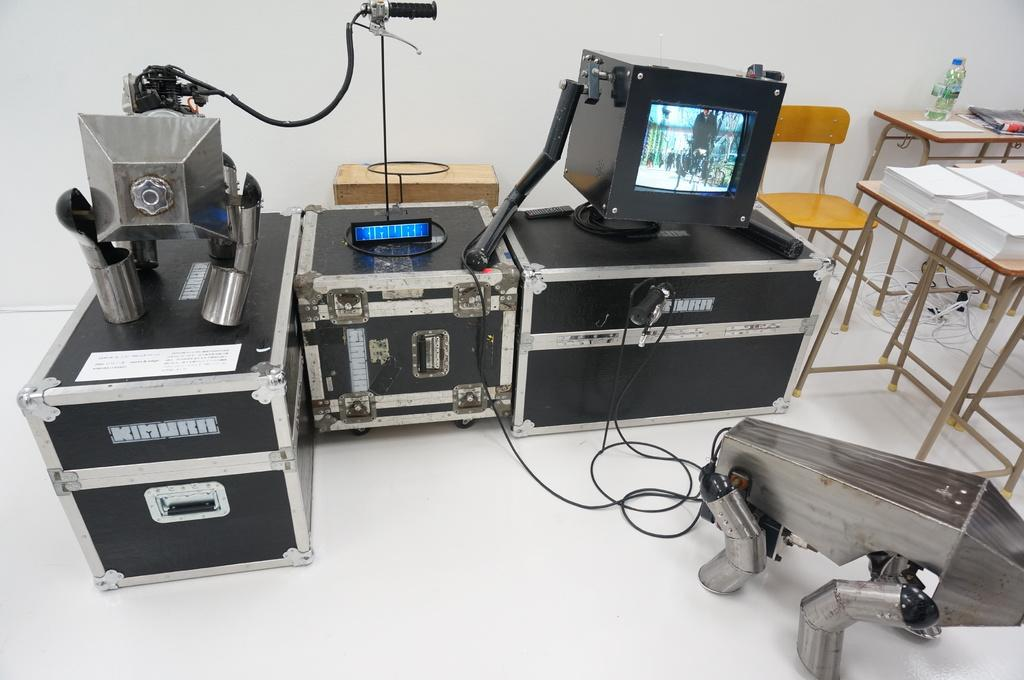What type of equipment can be seen in the image? There is equipment in the image, but the specific type is not mentioned. What electronic device is present in the image? There is a monitor in the image. What type of furniture is in the image? There are chairs and a table in the image. What is placed on the table in the image? Papers are placed on the table in the image. What can be seen in the background of the image? There is a wall in the background of the image. How many clocks are hanging on the wall in the image? There is no mention of clocks in the image; only a wall is mentioned in the background. What type of farming equipment is present in the image? There is no farming equipment present in the image. What type of person might be sitting in the chairs in the image? The image does not provide information about the people who might be sitting in the chairs, so it is impossible to determine their profession or role. 